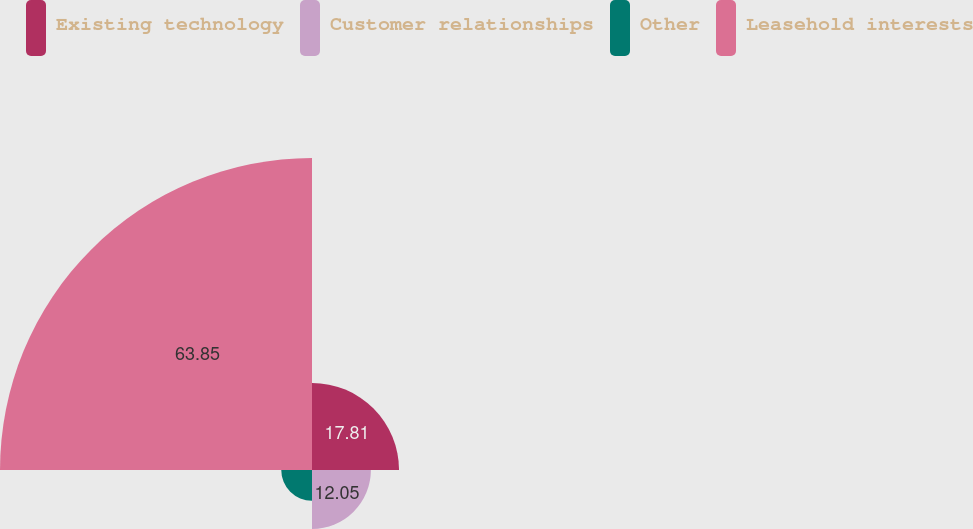Convert chart. <chart><loc_0><loc_0><loc_500><loc_500><pie_chart><fcel>Existing technology<fcel>Customer relationships<fcel>Other<fcel>Leasehold interests<nl><fcel>17.81%<fcel>12.05%<fcel>6.29%<fcel>63.85%<nl></chart> 